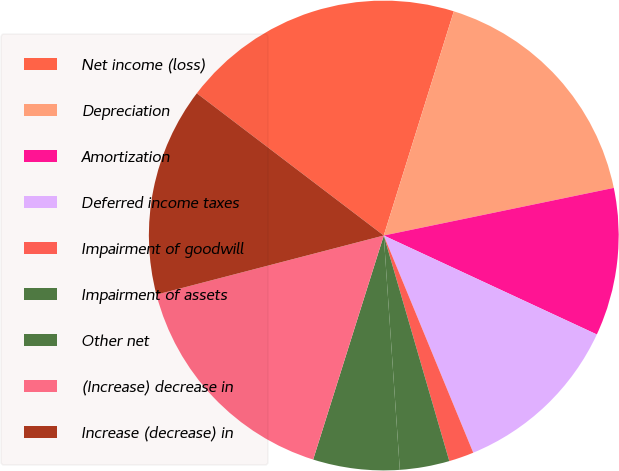<chart> <loc_0><loc_0><loc_500><loc_500><pie_chart><fcel>Net income (loss)<fcel>Depreciation<fcel>Amortization<fcel>Deferred income taxes<fcel>Impairment of goodwill<fcel>Impairment of assets<fcel>Other net<fcel>(Increase) decrease in<fcel>Increase (decrease) in<nl><fcel>19.47%<fcel>16.93%<fcel>10.17%<fcel>11.86%<fcel>1.72%<fcel>3.41%<fcel>5.95%<fcel>16.09%<fcel>14.4%<nl></chart> 